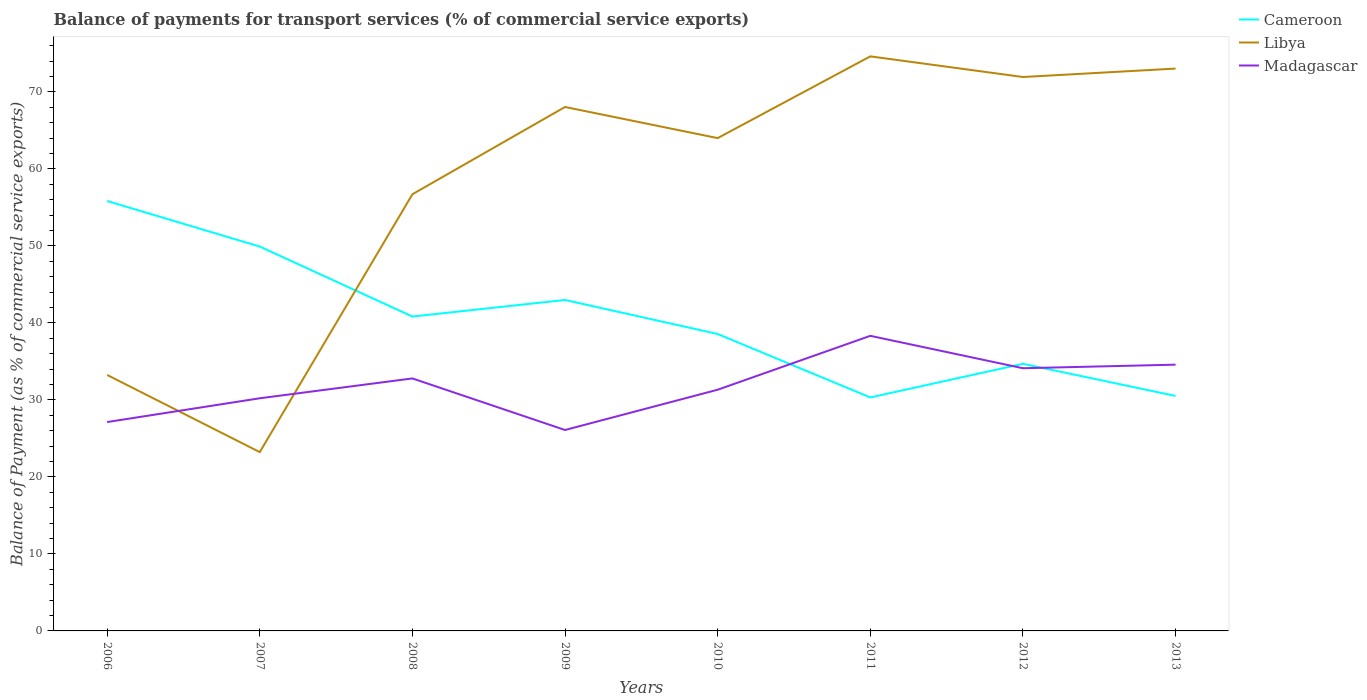Does the line corresponding to Cameroon intersect with the line corresponding to Libya?
Provide a short and direct response. Yes. Is the number of lines equal to the number of legend labels?
Your answer should be very brief. Yes. Across all years, what is the maximum balance of payments for transport services in Madagascar?
Offer a very short reply. 26.1. What is the total balance of payments for transport services in Libya in the graph?
Offer a terse response. -41.38. What is the difference between the highest and the second highest balance of payments for transport services in Libya?
Give a very brief answer. 51.4. What is the difference between the highest and the lowest balance of payments for transport services in Libya?
Ensure brevity in your answer.  5. Is the balance of payments for transport services in Cameroon strictly greater than the balance of payments for transport services in Libya over the years?
Ensure brevity in your answer.  No. How many lines are there?
Provide a short and direct response. 3. How many years are there in the graph?
Keep it short and to the point. 8. Does the graph contain any zero values?
Offer a terse response. No. How many legend labels are there?
Keep it short and to the point. 3. How are the legend labels stacked?
Keep it short and to the point. Vertical. What is the title of the graph?
Provide a succinct answer. Balance of payments for transport services (% of commercial service exports). Does "Vanuatu" appear as one of the legend labels in the graph?
Offer a very short reply. No. What is the label or title of the Y-axis?
Provide a succinct answer. Balance of Payment (as % of commercial service exports). What is the Balance of Payment (as % of commercial service exports) in Cameroon in 2006?
Your answer should be compact. 55.84. What is the Balance of Payment (as % of commercial service exports) of Libya in 2006?
Make the answer very short. 33.25. What is the Balance of Payment (as % of commercial service exports) of Madagascar in 2006?
Keep it short and to the point. 27.13. What is the Balance of Payment (as % of commercial service exports) of Cameroon in 2007?
Offer a terse response. 49.92. What is the Balance of Payment (as % of commercial service exports) of Libya in 2007?
Keep it short and to the point. 23.23. What is the Balance of Payment (as % of commercial service exports) in Madagascar in 2007?
Provide a short and direct response. 30.22. What is the Balance of Payment (as % of commercial service exports) in Cameroon in 2008?
Make the answer very short. 40.83. What is the Balance of Payment (as % of commercial service exports) in Libya in 2008?
Your answer should be very brief. 56.72. What is the Balance of Payment (as % of commercial service exports) in Madagascar in 2008?
Make the answer very short. 32.8. What is the Balance of Payment (as % of commercial service exports) of Cameroon in 2009?
Offer a very short reply. 42.99. What is the Balance of Payment (as % of commercial service exports) in Libya in 2009?
Your response must be concise. 68.05. What is the Balance of Payment (as % of commercial service exports) of Madagascar in 2009?
Ensure brevity in your answer.  26.1. What is the Balance of Payment (as % of commercial service exports) in Cameroon in 2010?
Offer a very short reply. 38.57. What is the Balance of Payment (as % of commercial service exports) in Libya in 2010?
Make the answer very short. 64.01. What is the Balance of Payment (as % of commercial service exports) of Madagascar in 2010?
Your response must be concise. 31.33. What is the Balance of Payment (as % of commercial service exports) of Cameroon in 2011?
Provide a succinct answer. 30.33. What is the Balance of Payment (as % of commercial service exports) in Libya in 2011?
Offer a terse response. 74.63. What is the Balance of Payment (as % of commercial service exports) of Madagascar in 2011?
Provide a short and direct response. 38.33. What is the Balance of Payment (as % of commercial service exports) in Cameroon in 2012?
Your answer should be compact. 34.69. What is the Balance of Payment (as % of commercial service exports) in Libya in 2012?
Give a very brief answer. 71.94. What is the Balance of Payment (as % of commercial service exports) of Madagascar in 2012?
Give a very brief answer. 34.12. What is the Balance of Payment (as % of commercial service exports) of Cameroon in 2013?
Offer a terse response. 30.52. What is the Balance of Payment (as % of commercial service exports) in Libya in 2013?
Keep it short and to the point. 73.04. What is the Balance of Payment (as % of commercial service exports) in Madagascar in 2013?
Provide a succinct answer. 34.58. Across all years, what is the maximum Balance of Payment (as % of commercial service exports) of Cameroon?
Your response must be concise. 55.84. Across all years, what is the maximum Balance of Payment (as % of commercial service exports) in Libya?
Provide a short and direct response. 74.63. Across all years, what is the maximum Balance of Payment (as % of commercial service exports) in Madagascar?
Your response must be concise. 38.33. Across all years, what is the minimum Balance of Payment (as % of commercial service exports) of Cameroon?
Offer a terse response. 30.33. Across all years, what is the minimum Balance of Payment (as % of commercial service exports) of Libya?
Offer a very short reply. 23.23. Across all years, what is the minimum Balance of Payment (as % of commercial service exports) of Madagascar?
Provide a short and direct response. 26.1. What is the total Balance of Payment (as % of commercial service exports) of Cameroon in the graph?
Your answer should be very brief. 323.69. What is the total Balance of Payment (as % of commercial service exports) of Libya in the graph?
Offer a terse response. 464.86. What is the total Balance of Payment (as % of commercial service exports) in Madagascar in the graph?
Provide a succinct answer. 254.6. What is the difference between the Balance of Payment (as % of commercial service exports) in Cameroon in 2006 and that in 2007?
Your answer should be compact. 5.92. What is the difference between the Balance of Payment (as % of commercial service exports) of Libya in 2006 and that in 2007?
Make the answer very short. 10.02. What is the difference between the Balance of Payment (as % of commercial service exports) in Madagascar in 2006 and that in 2007?
Offer a terse response. -3.09. What is the difference between the Balance of Payment (as % of commercial service exports) of Cameroon in 2006 and that in 2008?
Your answer should be compact. 15.01. What is the difference between the Balance of Payment (as % of commercial service exports) in Libya in 2006 and that in 2008?
Your answer should be very brief. -23.47. What is the difference between the Balance of Payment (as % of commercial service exports) in Madagascar in 2006 and that in 2008?
Make the answer very short. -5.67. What is the difference between the Balance of Payment (as % of commercial service exports) in Cameroon in 2006 and that in 2009?
Your answer should be very brief. 12.85. What is the difference between the Balance of Payment (as % of commercial service exports) of Libya in 2006 and that in 2009?
Your response must be concise. -34.81. What is the difference between the Balance of Payment (as % of commercial service exports) of Madagascar in 2006 and that in 2009?
Offer a very short reply. 1.03. What is the difference between the Balance of Payment (as % of commercial service exports) of Cameroon in 2006 and that in 2010?
Make the answer very short. 17.27. What is the difference between the Balance of Payment (as % of commercial service exports) of Libya in 2006 and that in 2010?
Your answer should be compact. -30.76. What is the difference between the Balance of Payment (as % of commercial service exports) of Madagascar in 2006 and that in 2010?
Your answer should be compact. -4.2. What is the difference between the Balance of Payment (as % of commercial service exports) in Cameroon in 2006 and that in 2011?
Provide a short and direct response. 25.51. What is the difference between the Balance of Payment (as % of commercial service exports) of Libya in 2006 and that in 2011?
Keep it short and to the point. -41.38. What is the difference between the Balance of Payment (as % of commercial service exports) of Madagascar in 2006 and that in 2011?
Your response must be concise. -11.2. What is the difference between the Balance of Payment (as % of commercial service exports) of Cameroon in 2006 and that in 2012?
Make the answer very short. 21.15. What is the difference between the Balance of Payment (as % of commercial service exports) of Libya in 2006 and that in 2012?
Your response must be concise. -38.7. What is the difference between the Balance of Payment (as % of commercial service exports) of Madagascar in 2006 and that in 2012?
Provide a short and direct response. -6.99. What is the difference between the Balance of Payment (as % of commercial service exports) of Cameroon in 2006 and that in 2013?
Give a very brief answer. 25.32. What is the difference between the Balance of Payment (as % of commercial service exports) of Libya in 2006 and that in 2013?
Your response must be concise. -39.79. What is the difference between the Balance of Payment (as % of commercial service exports) of Madagascar in 2006 and that in 2013?
Offer a terse response. -7.46. What is the difference between the Balance of Payment (as % of commercial service exports) in Cameroon in 2007 and that in 2008?
Provide a succinct answer. 9.09. What is the difference between the Balance of Payment (as % of commercial service exports) in Libya in 2007 and that in 2008?
Give a very brief answer. -33.49. What is the difference between the Balance of Payment (as % of commercial service exports) of Madagascar in 2007 and that in 2008?
Make the answer very short. -2.58. What is the difference between the Balance of Payment (as % of commercial service exports) in Cameroon in 2007 and that in 2009?
Provide a short and direct response. 6.94. What is the difference between the Balance of Payment (as % of commercial service exports) in Libya in 2007 and that in 2009?
Keep it short and to the point. -44.83. What is the difference between the Balance of Payment (as % of commercial service exports) of Madagascar in 2007 and that in 2009?
Provide a succinct answer. 4.12. What is the difference between the Balance of Payment (as % of commercial service exports) in Cameroon in 2007 and that in 2010?
Give a very brief answer. 11.36. What is the difference between the Balance of Payment (as % of commercial service exports) in Libya in 2007 and that in 2010?
Provide a short and direct response. -40.78. What is the difference between the Balance of Payment (as % of commercial service exports) of Madagascar in 2007 and that in 2010?
Your response must be concise. -1.11. What is the difference between the Balance of Payment (as % of commercial service exports) in Cameroon in 2007 and that in 2011?
Make the answer very short. 19.6. What is the difference between the Balance of Payment (as % of commercial service exports) in Libya in 2007 and that in 2011?
Give a very brief answer. -51.4. What is the difference between the Balance of Payment (as % of commercial service exports) in Madagascar in 2007 and that in 2011?
Offer a very short reply. -8.11. What is the difference between the Balance of Payment (as % of commercial service exports) of Cameroon in 2007 and that in 2012?
Your response must be concise. 15.23. What is the difference between the Balance of Payment (as % of commercial service exports) of Libya in 2007 and that in 2012?
Offer a terse response. -48.72. What is the difference between the Balance of Payment (as % of commercial service exports) of Madagascar in 2007 and that in 2012?
Provide a short and direct response. -3.9. What is the difference between the Balance of Payment (as % of commercial service exports) of Cameroon in 2007 and that in 2013?
Offer a terse response. 19.4. What is the difference between the Balance of Payment (as % of commercial service exports) in Libya in 2007 and that in 2013?
Your answer should be very brief. -49.81. What is the difference between the Balance of Payment (as % of commercial service exports) in Madagascar in 2007 and that in 2013?
Keep it short and to the point. -4.37. What is the difference between the Balance of Payment (as % of commercial service exports) in Cameroon in 2008 and that in 2009?
Make the answer very short. -2.15. What is the difference between the Balance of Payment (as % of commercial service exports) of Libya in 2008 and that in 2009?
Make the answer very short. -11.34. What is the difference between the Balance of Payment (as % of commercial service exports) in Madagascar in 2008 and that in 2009?
Offer a very short reply. 6.7. What is the difference between the Balance of Payment (as % of commercial service exports) in Cameroon in 2008 and that in 2010?
Your response must be concise. 2.27. What is the difference between the Balance of Payment (as % of commercial service exports) of Libya in 2008 and that in 2010?
Provide a short and direct response. -7.29. What is the difference between the Balance of Payment (as % of commercial service exports) of Madagascar in 2008 and that in 2010?
Make the answer very short. 1.47. What is the difference between the Balance of Payment (as % of commercial service exports) in Cameroon in 2008 and that in 2011?
Your response must be concise. 10.51. What is the difference between the Balance of Payment (as % of commercial service exports) of Libya in 2008 and that in 2011?
Keep it short and to the point. -17.91. What is the difference between the Balance of Payment (as % of commercial service exports) in Madagascar in 2008 and that in 2011?
Ensure brevity in your answer.  -5.53. What is the difference between the Balance of Payment (as % of commercial service exports) of Cameroon in 2008 and that in 2012?
Provide a succinct answer. 6.14. What is the difference between the Balance of Payment (as % of commercial service exports) of Libya in 2008 and that in 2012?
Make the answer very short. -15.23. What is the difference between the Balance of Payment (as % of commercial service exports) in Madagascar in 2008 and that in 2012?
Ensure brevity in your answer.  -1.32. What is the difference between the Balance of Payment (as % of commercial service exports) in Cameroon in 2008 and that in 2013?
Your response must be concise. 10.31. What is the difference between the Balance of Payment (as % of commercial service exports) of Libya in 2008 and that in 2013?
Your answer should be compact. -16.32. What is the difference between the Balance of Payment (as % of commercial service exports) in Madagascar in 2008 and that in 2013?
Provide a succinct answer. -1.79. What is the difference between the Balance of Payment (as % of commercial service exports) of Cameroon in 2009 and that in 2010?
Offer a very short reply. 4.42. What is the difference between the Balance of Payment (as % of commercial service exports) of Libya in 2009 and that in 2010?
Make the answer very short. 4.04. What is the difference between the Balance of Payment (as % of commercial service exports) in Madagascar in 2009 and that in 2010?
Provide a succinct answer. -5.23. What is the difference between the Balance of Payment (as % of commercial service exports) of Cameroon in 2009 and that in 2011?
Keep it short and to the point. 12.66. What is the difference between the Balance of Payment (as % of commercial service exports) of Libya in 2009 and that in 2011?
Provide a short and direct response. -6.57. What is the difference between the Balance of Payment (as % of commercial service exports) of Madagascar in 2009 and that in 2011?
Give a very brief answer. -12.23. What is the difference between the Balance of Payment (as % of commercial service exports) in Cameroon in 2009 and that in 2012?
Your response must be concise. 8.29. What is the difference between the Balance of Payment (as % of commercial service exports) of Libya in 2009 and that in 2012?
Your answer should be compact. -3.89. What is the difference between the Balance of Payment (as % of commercial service exports) of Madagascar in 2009 and that in 2012?
Make the answer very short. -8.02. What is the difference between the Balance of Payment (as % of commercial service exports) of Cameroon in 2009 and that in 2013?
Your response must be concise. 12.46. What is the difference between the Balance of Payment (as % of commercial service exports) of Libya in 2009 and that in 2013?
Offer a very short reply. -4.99. What is the difference between the Balance of Payment (as % of commercial service exports) of Madagascar in 2009 and that in 2013?
Ensure brevity in your answer.  -8.49. What is the difference between the Balance of Payment (as % of commercial service exports) in Cameroon in 2010 and that in 2011?
Give a very brief answer. 8.24. What is the difference between the Balance of Payment (as % of commercial service exports) of Libya in 2010 and that in 2011?
Your response must be concise. -10.62. What is the difference between the Balance of Payment (as % of commercial service exports) in Madagascar in 2010 and that in 2011?
Ensure brevity in your answer.  -7. What is the difference between the Balance of Payment (as % of commercial service exports) of Cameroon in 2010 and that in 2012?
Provide a short and direct response. 3.87. What is the difference between the Balance of Payment (as % of commercial service exports) of Libya in 2010 and that in 2012?
Offer a terse response. -7.94. What is the difference between the Balance of Payment (as % of commercial service exports) of Madagascar in 2010 and that in 2012?
Make the answer very short. -2.79. What is the difference between the Balance of Payment (as % of commercial service exports) of Cameroon in 2010 and that in 2013?
Offer a terse response. 8.05. What is the difference between the Balance of Payment (as % of commercial service exports) in Libya in 2010 and that in 2013?
Offer a terse response. -9.03. What is the difference between the Balance of Payment (as % of commercial service exports) of Madagascar in 2010 and that in 2013?
Your response must be concise. -3.26. What is the difference between the Balance of Payment (as % of commercial service exports) in Cameroon in 2011 and that in 2012?
Keep it short and to the point. -4.37. What is the difference between the Balance of Payment (as % of commercial service exports) of Libya in 2011 and that in 2012?
Make the answer very short. 2.68. What is the difference between the Balance of Payment (as % of commercial service exports) of Madagascar in 2011 and that in 2012?
Give a very brief answer. 4.21. What is the difference between the Balance of Payment (as % of commercial service exports) in Cameroon in 2011 and that in 2013?
Keep it short and to the point. -0.2. What is the difference between the Balance of Payment (as % of commercial service exports) of Libya in 2011 and that in 2013?
Give a very brief answer. 1.59. What is the difference between the Balance of Payment (as % of commercial service exports) in Madagascar in 2011 and that in 2013?
Your answer should be compact. 3.74. What is the difference between the Balance of Payment (as % of commercial service exports) in Cameroon in 2012 and that in 2013?
Your response must be concise. 4.17. What is the difference between the Balance of Payment (as % of commercial service exports) of Libya in 2012 and that in 2013?
Give a very brief answer. -1.1. What is the difference between the Balance of Payment (as % of commercial service exports) in Madagascar in 2012 and that in 2013?
Give a very brief answer. -0.46. What is the difference between the Balance of Payment (as % of commercial service exports) in Cameroon in 2006 and the Balance of Payment (as % of commercial service exports) in Libya in 2007?
Give a very brief answer. 32.61. What is the difference between the Balance of Payment (as % of commercial service exports) in Cameroon in 2006 and the Balance of Payment (as % of commercial service exports) in Madagascar in 2007?
Provide a succinct answer. 25.62. What is the difference between the Balance of Payment (as % of commercial service exports) of Libya in 2006 and the Balance of Payment (as % of commercial service exports) of Madagascar in 2007?
Offer a terse response. 3.03. What is the difference between the Balance of Payment (as % of commercial service exports) of Cameroon in 2006 and the Balance of Payment (as % of commercial service exports) of Libya in 2008?
Your response must be concise. -0.88. What is the difference between the Balance of Payment (as % of commercial service exports) of Cameroon in 2006 and the Balance of Payment (as % of commercial service exports) of Madagascar in 2008?
Offer a terse response. 23.04. What is the difference between the Balance of Payment (as % of commercial service exports) of Libya in 2006 and the Balance of Payment (as % of commercial service exports) of Madagascar in 2008?
Provide a short and direct response. 0.45. What is the difference between the Balance of Payment (as % of commercial service exports) of Cameroon in 2006 and the Balance of Payment (as % of commercial service exports) of Libya in 2009?
Provide a short and direct response. -12.21. What is the difference between the Balance of Payment (as % of commercial service exports) of Cameroon in 2006 and the Balance of Payment (as % of commercial service exports) of Madagascar in 2009?
Provide a short and direct response. 29.74. What is the difference between the Balance of Payment (as % of commercial service exports) of Libya in 2006 and the Balance of Payment (as % of commercial service exports) of Madagascar in 2009?
Keep it short and to the point. 7.15. What is the difference between the Balance of Payment (as % of commercial service exports) of Cameroon in 2006 and the Balance of Payment (as % of commercial service exports) of Libya in 2010?
Provide a succinct answer. -8.17. What is the difference between the Balance of Payment (as % of commercial service exports) of Cameroon in 2006 and the Balance of Payment (as % of commercial service exports) of Madagascar in 2010?
Provide a succinct answer. 24.51. What is the difference between the Balance of Payment (as % of commercial service exports) in Libya in 2006 and the Balance of Payment (as % of commercial service exports) in Madagascar in 2010?
Give a very brief answer. 1.92. What is the difference between the Balance of Payment (as % of commercial service exports) of Cameroon in 2006 and the Balance of Payment (as % of commercial service exports) of Libya in 2011?
Offer a terse response. -18.79. What is the difference between the Balance of Payment (as % of commercial service exports) of Cameroon in 2006 and the Balance of Payment (as % of commercial service exports) of Madagascar in 2011?
Provide a short and direct response. 17.51. What is the difference between the Balance of Payment (as % of commercial service exports) in Libya in 2006 and the Balance of Payment (as % of commercial service exports) in Madagascar in 2011?
Your response must be concise. -5.08. What is the difference between the Balance of Payment (as % of commercial service exports) of Cameroon in 2006 and the Balance of Payment (as % of commercial service exports) of Libya in 2012?
Keep it short and to the point. -16.11. What is the difference between the Balance of Payment (as % of commercial service exports) of Cameroon in 2006 and the Balance of Payment (as % of commercial service exports) of Madagascar in 2012?
Your response must be concise. 21.72. What is the difference between the Balance of Payment (as % of commercial service exports) of Libya in 2006 and the Balance of Payment (as % of commercial service exports) of Madagascar in 2012?
Your response must be concise. -0.87. What is the difference between the Balance of Payment (as % of commercial service exports) in Cameroon in 2006 and the Balance of Payment (as % of commercial service exports) in Libya in 2013?
Provide a succinct answer. -17.2. What is the difference between the Balance of Payment (as % of commercial service exports) in Cameroon in 2006 and the Balance of Payment (as % of commercial service exports) in Madagascar in 2013?
Your answer should be compact. 21.26. What is the difference between the Balance of Payment (as % of commercial service exports) in Libya in 2006 and the Balance of Payment (as % of commercial service exports) in Madagascar in 2013?
Provide a short and direct response. -1.34. What is the difference between the Balance of Payment (as % of commercial service exports) of Cameroon in 2007 and the Balance of Payment (as % of commercial service exports) of Libya in 2008?
Your answer should be very brief. -6.79. What is the difference between the Balance of Payment (as % of commercial service exports) in Cameroon in 2007 and the Balance of Payment (as % of commercial service exports) in Madagascar in 2008?
Make the answer very short. 17.13. What is the difference between the Balance of Payment (as % of commercial service exports) of Libya in 2007 and the Balance of Payment (as % of commercial service exports) of Madagascar in 2008?
Offer a very short reply. -9.57. What is the difference between the Balance of Payment (as % of commercial service exports) of Cameroon in 2007 and the Balance of Payment (as % of commercial service exports) of Libya in 2009?
Offer a terse response. -18.13. What is the difference between the Balance of Payment (as % of commercial service exports) of Cameroon in 2007 and the Balance of Payment (as % of commercial service exports) of Madagascar in 2009?
Offer a very short reply. 23.83. What is the difference between the Balance of Payment (as % of commercial service exports) in Libya in 2007 and the Balance of Payment (as % of commercial service exports) in Madagascar in 2009?
Provide a succinct answer. -2.87. What is the difference between the Balance of Payment (as % of commercial service exports) in Cameroon in 2007 and the Balance of Payment (as % of commercial service exports) in Libya in 2010?
Provide a succinct answer. -14.09. What is the difference between the Balance of Payment (as % of commercial service exports) in Cameroon in 2007 and the Balance of Payment (as % of commercial service exports) in Madagascar in 2010?
Offer a very short reply. 18.59. What is the difference between the Balance of Payment (as % of commercial service exports) of Libya in 2007 and the Balance of Payment (as % of commercial service exports) of Madagascar in 2010?
Provide a succinct answer. -8.1. What is the difference between the Balance of Payment (as % of commercial service exports) of Cameroon in 2007 and the Balance of Payment (as % of commercial service exports) of Libya in 2011?
Make the answer very short. -24.7. What is the difference between the Balance of Payment (as % of commercial service exports) in Cameroon in 2007 and the Balance of Payment (as % of commercial service exports) in Madagascar in 2011?
Ensure brevity in your answer.  11.59. What is the difference between the Balance of Payment (as % of commercial service exports) of Libya in 2007 and the Balance of Payment (as % of commercial service exports) of Madagascar in 2011?
Offer a terse response. -15.1. What is the difference between the Balance of Payment (as % of commercial service exports) in Cameroon in 2007 and the Balance of Payment (as % of commercial service exports) in Libya in 2012?
Offer a terse response. -22.02. What is the difference between the Balance of Payment (as % of commercial service exports) of Cameroon in 2007 and the Balance of Payment (as % of commercial service exports) of Madagascar in 2012?
Give a very brief answer. 15.8. What is the difference between the Balance of Payment (as % of commercial service exports) of Libya in 2007 and the Balance of Payment (as % of commercial service exports) of Madagascar in 2012?
Your answer should be very brief. -10.89. What is the difference between the Balance of Payment (as % of commercial service exports) of Cameroon in 2007 and the Balance of Payment (as % of commercial service exports) of Libya in 2013?
Ensure brevity in your answer.  -23.12. What is the difference between the Balance of Payment (as % of commercial service exports) of Cameroon in 2007 and the Balance of Payment (as % of commercial service exports) of Madagascar in 2013?
Your answer should be very brief. 15.34. What is the difference between the Balance of Payment (as % of commercial service exports) in Libya in 2007 and the Balance of Payment (as % of commercial service exports) in Madagascar in 2013?
Offer a terse response. -11.36. What is the difference between the Balance of Payment (as % of commercial service exports) in Cameroon in 2008 and the Balance of Payment (as % of commercial service exports) in Libya in 2009?
Offer a very short reply. -27.22. What is the difference between the Balance of Payment (as % of commercial service exports) in Cameroon in 2008 and the Balance of Payment (as % of commercial service exports) in Madagascar in 2009?
Keep it short and to the point. 14.74. What is the difference between the Balance of Payment (as % of commercial service exports) of Libya in 2008 and the Balance of Payment (as % of commercial service exports) of Madagascar in 2009?
Make the answer very short. 30.62. What is the difference between the Balance of Payment (as % of commercial service exports) in Cameroon in 2008 and the Balance of Payment (as % of commercial service exports) in Libya in 2010?
Your answer should be compact. -23.18. What is the difference between the Balance of Payment (as % of commercial service exports) in Cameroon in 2008 and the Balance of Payment (as % of commercial service exports) in Madagascar in 2010?
Your answer should be very brief. 9.51. What is the difference between the Balance of Payment (as % of commercial service exports) of Libya in 2008 and the Balance of Payment (as % of commercial service exports) of Madagascar in 2010?
Give a very brief answer. 25.39. What is the difference between the Balance of Payment (as % of commercial service exports) of Cameroon in 2008 and the Balance of Payment (as % of commercial service exports) of Libya in 2011?
Your answer should be very brief. -33.79. What is the difference between the Balance of Payment (as % of commercial service exports) in Cameroon in 2008 and the Balance of Payment (as % of commercial service exports) in Madagascar in 2011?
Provide a short and direct response. 2.51. What is the difference between the Balance of Payment (as % of commercial service exports) in Libya in 2008 and the Balance of Payment (as % of commercial service exports) in Madagascar in 2011?
Ensure brevity in your answer.  18.39. What is the difference between the Balance of Payment (as % of commercial service exports) of Cameroon in 2008 and the Balance of Payment (as % of commercial service exports) of Libya in 2012?
Your answer should be compact. -31.11. What is the difference between the Balance of Payment (as % of commercial service exports) of Cameroon in 2008 and the Balance of Payment (as % of commercial service exports) of Madagascar in 2012?
Your response must be concise. 6.71. What is the difference between the Balance of Payment (as % of commercial service exports) of Libya in 2008 and the Balance of Payment (as % of commercial service exports) of Madagascar in 2012?
Your response must be concise. 22.6. What is the difference between the Balance of Payment (as % of commercial service exports) in Cameroon in 2008 and the Balance of Payment (as % of commercial service exports) in Libya in 2013?
Offer a very short reply. -32.21. What is the difference between the Balance of Payment (as % of commercial service exports) in Cameroon in 2008 and the Balance of Payment (as % of commercial service exports) in Madagascar in 2013?
Your answer should be very brief. 6.25. What is the difference between the Balance of Payment (as % of commercial service exports) of Libya in 2008 and the Balance of Payment (as % of commercial service exports) of Madagascar in 2013?
Your answer should be compact. 22.13. What is the difference between the Balance of Payment (as % of commercial service exports) in Cameroon in 2009 and the Balance of Payment (as % of commercial service exports) in Libya in 2010?
Your answer should be very brief. -21.02. What is the difference between the Balance of Payment (as % of commercial service exports) in Cameroon in 2009 and the Balance of Payment (as % of commercial service exports) in Madagascar in 2010?
Your answer should be very brief. 11.66. What is the difference between the Balance of Payment (as % of commercial service exports) in Libya in 2009 and the Balance of Payment (as % of commercial service exports) in Madagascar in 2010?
Keep it short and to the point. 36.72. What is the difference between the Balance of Payment (as % of commercial service exports) of Cameroon in 2009 and the Balance of Payment (as % of commercial service exports) of Libya in 2011?
Your answer should be compact. -31.64. What is the difference between the Balance of Payment (as % of commercial service exports) of Cameroon in 2009 and the Balance of Payment (as % of commercial service exports) of Madagascar in 2011?
Your answer should be compact. 4.66. What is the difference between the Balance of Payment (as % of commercial service exports) in Libya in 2009 and the Balance of Payment (as % of commercial service exports) in Madagascar in 2011?
Your answer should be very brief. 29.72. What is the difference between the Balance of Payment (as % of commercial service exports) of Cameroon in 2009 and the Balance of Payment (as % of commercial service exports) of Libya in 2012?
Ensure brevity in your answer.  -28.96. What is the difference between the Balance of Payment (as % of commercial service exports) in Cameroon in 2009 and the Balance of Payment (as % of commercial service exports) in Madagascar in 2012?
Ensure brevity in your answer.  8.87. What is the difference between the Balance of Payment (as % of commercial service exports) of Libya in 2009 and the Balance of Payment (as % of commercial service exports) of Madagascar in 2012?
Keep it short and to the point. 33.93. What is the difference between the Balance of Payment (as % of commercial service exports) in Cameroon in 2009 and the Balance of Payment (as % of commercial service exports) in Libya in 2013?
Provide a succinct answer. -30.05. What is the difference between the Balance of Payment (as % of commercial service exports) of Cameroon in 2009 and the Balance of Payment (as % of commercial service exports) of Madagascar in 2013?
Provide a short and direct response. 8.4. What is the difference between the Balance of Payment (as % of commercial service exports) of Libya in 2009 and the Balance of Payment (as % of commercial service exports) of Madagascar in 2013?
Your answer should be compact. 33.47. What is the difference between the Balance of Payment (as % of commercial service exports) of Cameroon in 2010 and the Balance of Payment (as % of commercial service exports) of Libya in 2011?
Offer a very short reply. -36.06. What is the difference between the Balance of Payment (as % of commercial service exports) of Cameroon in 2010 and the Balance of Payment (as % of commercial service exports) of Madagascar in 2011?
Give a very brief answer. 0.24. What is the difference between the Balance of Payment (as % of commercial service exports) of Libya in 2010 and the Balance of Payment (as % of commercial service exports) of Madagascar in 2011?
Ensure brevity in your answer.  25.68. What is the difference between the Balance of Payment (as % of commercial service exports) of Cameroon in 2010 and the Balance of Payment (as % of commercial service exports) of Libya in 2012?
Ensure brevity in your answer.  -33.38. What is the difference between the Balance of Payment (as % of commercial service exports) of Cameroon in 2010 and the Balance of Payment (as % of commercial service exports) of Madagascar in 2012?
Provide a succinct answer. 4.45. What is the difference between the Balance of Payment (as % of commercial service exports) in Libya in 2010 and the Balance of Payment (as % of commercial service exports) in Madagascar in 2012?
Your answer should be compact. 29.89. What is the difference between the Balance of Payment (as % of commercial service exports) of Cameroon in 2010 and the Balance of Payment (as % of commercial service exports) of Libya in 2013?
Keep it short and to the point. -34.47. What is the difference between the Balance of Payment (as % of commercial service exports) of Cameroon in 2010 and the Balance of Payment (as % of commercial service exports) of Madagascar in 2013?
Provide a short and direct response. 3.98. What is the difference between the Balance of Payment (as % of commercial service exports) of Libya in 2010 and the Balance of Payment (as % of commercial service exports) of Madagascar in 2013?
Provide a short and direct response. 29.43. What is the difference between the Balance of Payment (as % of commercial service exports) in Cameroon in 2011 and the Balance of Payment (as % of commercial service exports) in Libya in 2012?
Make the answer very short. -41.62. What is the difference between the Balance of Payment (as % of commercial service exports) of Cameroon in 2011 and the Balance of Payment (as % of commercial service exports) of Madagascar in 2012?
Your answer should be compact. -3.79. What is the difference between the Balance of Payment (as % of commercial service exports) in Libya in 2011 and the Balance of Payment (as % of commercial service exports) in Madagascar in 2012?
Your answer should be very brief. 40.51. What is the difference between the Balance of Payment (as % of commercial service exports) in Cameroon in 2011 and the Balance of Payment (as % of commercial service exports) in Libya in 2013?
Keep it short and to the point. -42.72. What is the difference between the Balance of Payment (as % of commercial service exports) in Cameroon in 2011 and the Balance of Payment (as % of commercial service exports) in Madagascar in 2013?
Provide a short and direct response. -4.26. What is the difference between the Balance of Payment (as % of commercial service exports) of Libya in 2011 and the Balance of Payment (as % of commercial service exports) of Madagascar in 2013?
Provide a short and direct response. 40.04. What is the difference between the Balance of Payment (as % of commercial service exports) in Cameroon in 2012 and the Balance of Payment (as % of commercial service exports) in Libya in 2013?
Your answer should be compact. -38.35. What is the difference between the Balance of Payment (as % of commercial service exports) in Cameroon in 2012 and the Balance of Payment (as % of commercial service exports) in Madagascar in 2013?
Offer a very short reply. 0.11. What is the difference between the Balance of Payment (as % of commercial service exports) in Libya in 2012 and the Balance of Payment (as % of commercial service exports) in Madagascar in 2013?
Give a very brief answer. 37.36. What is the average Balance of Payment (as % of commercial service exports) of Cameroon per year?
Your answer should be compact. 40.46. What is the average Balance of Payment (as % of commercial service exports) in Libya per year?
Your answer should be compact. 58.11. What is the average Balance of Payment (as % of commercial service exports) in Madagascar per year?
Provide a succinct answer. 31.82. In the year 2006, what is the difference between the Balance of Payment (as % of commercial service exports) of Cameroon and Balance of Payment (as % of commercial service exports) of Libya?
Provide a succinct answer. 22.59. In the year 2006, what is the difference between the Balance of Payment (as % of commercial service exports) of Cameroon and Balance of Payment (as % of commercial service exports) of Madagascar?
Provide a succinct answer. 28.71. In the year 2006, what is the difference between the Balance of Payment (as % of commercial service exports) of Libya and Balance of Payment (as % of commercial service exports) of Madagascar?
Your answer should be compact. 6.12. In the year 2007, what is the difference between the Balance of Payment (as % of commercial service exports) of Cameroon and Balance of Payment (as % of commercial service exports) of Libya?
Offer a terse response. 26.7. In the year 2007, what is the difference between the Balance of Payment (as % of commercial service exports) in Cameroon and Balance of Payment (as % of commercial service exports) in Madagascar?
Provide a succinct answer. 19.7. In the year 2007, what is the difference between the Balance of Payment (as % of commercial service exports) of Libya and Balance of Payment (as % of commercial service exports) of Madagascar?
Your answer should be very brief. -6.99. In the year 2008, what is the difference between the Balance of Payment (as % of commercial service exports) in Cameroon and Balance of Payment (as % of commercial service exports) in Libya?
Offer a terse response. -15.88. In the year 2008, what is the difference between the Balance of Payment (as % of commercial service exports) of Cameroon and Balance of Payment (as % of commercial service exports) of Madagascar?
Your answer should be compact. 8.04. In the year 2008, what is the difference between the Balance of Payment (as % of commercial service exports) of Libya and Balance of Payment (as % of commercial service exports) of Madagascar?
Provide a short and direct response. 23.92. In the year 2009, what is the difference between the Balance of Payment (as % of commercial service exports) in Cameroon and Balance of Payment (as % of commercial service exports) in Libya?
Provide a short and direct response. -25.07. In the year 2009, what is the difference between the Balance of Payment (as % of commercial service exports) of Cameroon and Balance of Payment (as % of commercial service exports) of Madagascar?
Your answer should be very brief. 16.89. In the year 2009, what is the difference between the Balance of Payment (as % of commercial service exports) in Libya and Balance of Payment (as % of commercial service exports) in Madagascar?
Provide a short and direct response. 41.96. In the year 2010, what is the difference between the Balance of Payment (as % of commercial service exports) in Cameroon and Balance of Payment (as % of commercial service exports) in Libya?
Keep it short and to the point. -25.44. In the year 2010, what is the difference between the Balance of Payment (as % of commercial service exports) in Cameroon and Balance of Payment (as % of commercial service exports) in Madagascar?
Provide a succinct answer. 7.24. In the year 2010, what is the difference between the Balance of Payment (as % of commercial service exports) of Libya and Balance of Payment (as % of commercial service exports) of Madagascar?
Your answer should be very brief. 32.68. In the year 2011, what is the difference between the Balance of Payment (as % of commercial service exports) in Cameroon and Balance of Payment (as % of commercial service exports) in Libya?
Your answer should be very brief. -44.3. In the year 2011, what is the difference between the Balance of Payment (as % of commercial service exports) of Cameroon and Balance of Payment (as % of commercial service exports) of Madagascar?
Offer a very short reply. -8. In the year 2011, what is the difference between the Balance of Payment (as % of commercial service exports) of Libya and Balance of Payment (as % of commercial service exports) of Madagascar?
Your response must be concise. 36.3. In the year 2012, what is the difference between the Balance of Payment (as % of commercial service exports) of Cameroon and Balance of Payment (as % of commercial service exports) of Libya?
Keep it short and to the point. -37.25. In the year 2012, what is the difference between the Balance of Payment (as % of commercial service exports) of Cameroon and Balance of Payment (as % of commercial service exports) of Madagascar?
Give a very brief answer. 0.57. In the year 2012, what is the difference between the Balance of Payment (as % of commercial service exports) in Libya and Balance of Payment (as % of commercial service exports) in Madagascar?
Offer a very short reply. 37.83. In the year 2013, what is the difference between the Balance of Payment (as % of commercial service exports) of Cameroon and Balance of Payment (as % of commercial service exports) of Libya?
Give a very brief answer. -42.52. In the year 2013, what is the difference between the Balance of Payment (as % of commercial service exports) of Cameroon and Balance of Payment (as % of commercial service exports) of Madagascar?
Provide a succinct answer. -4.06. In the year 2013, what is the difference between the Balance of Payment (as % of commercial service exports) in Libya and Balance of Payment (as % of commercial service exports) in Madagascar?
Give a very brief answer. 38.46. What is the ratio of the Balance of Payment (as % of commercial service exports) of Cameroon in 2006 to that in 2007?
Provide a succinct answer. 1.12. What is the ratio of the Balance of Payment (as % of commercial service exports) of Libya in 2006 to that in 2007?
Provide a short and direct response. 1.43. What is the ratio of the Balance of Payment (as % of commercial service exports) of Madagascar in 2006 to that in 2007?
Provide a succinct answer. 0.9. What is the ratio of the Balance of Payment (as % of commercial service exports) of Cameroon in 2006 to that in 2008?
Keep it short and to the point. 1.37. What is the ratio of the Balance of Payment (as % of commercial service exports) of Libya in 2006 to that in 2008?
Keep it short and to the point. 0.59. What is the ratio of the Balance of Payment (as % of commercial service exports) in Madagascar in 2006 to that in 2008?
Offer a very short reply. 0.83. What is the ratio of the Balance of Payment (as % of commercial service exports) in Cameroon in 2006 to that in 2009?
Provide a succinct answer. 1.3. What is the ratio of the Balance of Payment (as % of commercial service exports) in Libya in 2006 to that in 2009?
Give a very brief answer. 0.49. What is the ratio of the Balance of Payment (as % of commercial service exports) in Madagascar in 2006 to that in 2009?
Offer a very short reply. 1.04. What is the ratio of the Balance of Payment (as % of commercial service exports) of Cameroon in 2006 to that in 2010?
Your answer should be very brief. 1.45. What is the ratio of the Balance of Payment (as % of commercial service exports) in Libya in 2006 to that in 2010?
Provide a succinct answer. 0.52. What is the ratio of the Balance of Payment (as % of commercial service exports) of Madagascar in 2006 to that in 2010?
Give a very brief answer. 0.87. What is the ratio of the Balance of Payment (as % of commercial service exports) of Cameroon in 2006 to that in 2011?
Give a very brief answer. 1.84. What is the ratio of the Balance of Payment (as % of commercial service exports) of Libya in 2006 to that in 2011?
Give a very brief answer. 0.45. What is the ratio of the Balance of Payment (as % of commercial service exports) of Madagascar in 2006 to that in 2011?
Your answer should be very brief. 0.71. What is the ratio of the Balance of Payment (as % of commercial service exports) in Cameroon in 2006 to that in 2012?
Provide a short and direct response. 1.61. What is the ratio of the Balance of Payment (as % of commercial service exports) of Libya in 2006 to that in 2012?
Offer a terse response. 0.46. What is the ratio of the Balance of Payment (as % of commercial service exports) in Madagascar in 2006 to that in 2012?
Your answer should be compact. 0.8. What is the ratio of the Balance of Payment (as % of commercial service exports) in Cameroon in 2006 to that in 2013?
Your answer should be very brief. 1.83. What is the ratio of the Balance of Payment (as % of commercial service exports) in Libya in 2006 to that in 2013?
Ensure brevity in your answer.  0.46. What is the ratio of the Balance of Payment (as % of commercial service exports) of Madagascar in 2006 to that in 2013?
Give a very brief answer. 0.78. What is the ratio of the Balance of Payment (as % of commercial service exports) in Cameroon in 2007 to that in 2008?
Provide a succinct answer. 1.22. What is the ratio of the Balance of Payment (as % of commercial service exports) of Libya in 2007 to that in 2008?
Make the answer very short. 0.41. What is the ratio of the Balance of Payment (as % of commercial service exports) of Madagascar in 2007 to that in 2008?
Provide a short and direct response. 0.92. What is the ratio of the Balance of Payment (as % of commercial service exports) in Cameroon in 2007 to that in 2009?
Give a very brief answer. 1.16. What is the ratio of the Balance of Payment (as % of commercial service exports) in Libya in 2007 to that in 2009?
Keep it short and to the point. 0.34. What is the ratio of the Balance of Payment (as % of commercial service exports) of Madagascar in 2007 to that in 2009?
Provide a succinct answer. 1.16. What is the ratio of the Balance of Payment (as % of commercial service exports) in Cameroon in 2007 to that in 2010?
Give a very brief answer. 1.29. What is the ratio of the Balance of Payment (as % of commercial service exports) of Libya in 2007 to that in 2010?
Your answer should be compact. 0.36. What is the ratio of the Balance of Payment (as % of commercial service exports) in Madagascar in 2007 to that in 2010?
Your answer should be very brief. 0.96. What is the ratio of the Balance of Payment (as % of commercial service exports) of Cameroon in 2007 to that in 2011?
Keep it short and to the point. 1.65. What is the ratio of the Balance of Payment (as % of commercial service exports) of Libya in 2007 to that in 2011?
Make the answer very short. 0.31. What is the ratio of the Balance of Payment (as % of commercial service exports) in Madagascar in 2007 to that in 2011?
Keep it short and to the point. 0.79. What is the ratio of the Balance of Payment (as % of commercial service exports) of Cameroon in 2007 to that in 2012?
Provide a short and direct response. 1.44. What is the ratio of the Balance of Payment (as % of commercial service exports) in Libya in 2007 to that in 2012?
Your answer should be very brief. 0.32. What is the ratio of the Balance of Payment (as % of commercial service exports) of Madagascar in 2007 to that in 2012?
Offer a very short reply. 0.89. What is the ratio of the Balance of Payment (as % of commercial service exports) in Cameroon in 2007 to that in 2013?
Offer a very short reply. 1.64. What is the ratio of the Balance of Payment (as % of commercial service exports) in Libya in 2007 to that in 2013?
Offer a very short reply. 0.32. What is the ratio of the Balance of Payment (as % of commercial service exports) of Madagascar in 2007 to that in 2013?
Offer a terse response. 0.87. What is the ratio of the Balance of Payment (as % of commercial service exports) in Cameroon in 2008 to that in 2009?
Your response must be concise. 0.95. What is the ratio of the Balance of Payment (as % of commercial service exports) of Libya in 2008 to that in 2009?
Offer a terse response. 0.83. What is the ratio of the Balance of Payment (as % of commercial service exports) in Madagascar in 2008 to that in 2009?
Make the answer very short. 1.26. What is the ratio of the Balance of Payment (as % of commercial service exports) in Cameroon in 2008 to that in 2010?
Give a very brief answer. 1.06. What is the ratio of the Balance of Payment (as % of commercial service exports) of Libya in 2008 to that in 2010?
Make the answer very short. 0.89. What is the ratio of the Balance of Payment (as % of commercial service exports) of Madagascar in 2008 to that in 2010?
Provide a short and direct response. 1.05. What is the ratio of the Balance of Payment (as % of commercial service exports) in Cameroon in 2008 to that in 2011?
Provide a succinct answer. 1.35. What is the ratio of the Balance of Payment (as % of commercial service exports) in Libya in 2008 to that in 2011?
Offer a very short reply. 0.76. What is the ratio of the Balance of Payment (as % of commercial service exports) of Madagascar in 2008 to that in 2011?
Your response must be concise. 0.86. What is the ratio of the Balance of Payment (as % of commercial service exports) of Cameroon in 2008 to that in 2012?
Your answer should be compact. 1.18. What is the ratio of the Balance of Payment (as % of commercial service exports) of Libya in 2008 to that in 2012?
Your response must be concise. 0.79. What is the ratio of the Balance of Payment (as % of commercial service exports) in Madagascar in 2008 to that in 2012?
Your answer should be very brief. 0.96. What is the ratio of the Balance of Payment (as % of commercial service exports) of Cameroon in 2008 to that in 2013?
Give a very brief answer. 1.34. What is the ratio of the Balance of Payment (as % of commercial service exports) in Libya in 2008 to that in 2013?
Your answer should be compact. 0.78. What is the ratio of the Balance of Payment (as % of commercial service exports) of Madagascar in 2008 to that in 2013?
Give a very brief answer. 0.95. What is the ratio of the Balance of Payment (as % of commercial service exports) of Cameroon in 2009 to that in 2010?
Keep it short and to the point. 1.11. What is the ratio of the Balance of Payment (as % of commercial service exports) in Libya in 2009 to that in 2010?
Offer a terse response. 1.06. What is the ratio of the Balance of Payment (as % of commercial service exports) in Madagascar in 2009 to that in 2010?
Offer a terse response. 0.83. What is the ratio of the Balance of Payment (as % of commercial service exports) of Cameroon in 2009 to that in 2011?
Your answer should be very brief. 1.42. What is the ratio of the Balance of Payment (as % of commercial service exports) of Libya in 2009 to that in 2011?
Make the answer very short. 0.91. What is the ratio of the Balance of Payment (as % of commercial service exports) in Madagascar in 2009 to that in 2011?
Offer a terse response. 0.68. What is the ratio of the Balance of Payment (as % of commercial service exports) of Cameroon in 2009 to that in 2012?
Make the answer very short. 1.24. What is the ratio of the Balance of Payment (as % of commercial service exports) in Libya in 2009 to that in 2012?
Your answer should be compact. 0.95. What is the ratio of the Balance of Payment (as % of commercial service exports) in Madagascar in 2009 to that in 2012?
Offer a very short reply. 0.76. What is the ratio of the Balance of Payment (as % of commercial service exports) of Cameroon in 2009 to that in 2013?
Provide a short and direct response. 1.41. What is the ratio of the Balance of Payment (as % of commercial service exports) of Libya in 2009 to that in 2013?
Provide a succinct answer. 0.93. What is the ratio of the Balance of Payment (as % of commercial service exports) in Madagascar in 2009 to that in 2013?
Your answer should be compact. 0.75. What is the ratio of the Balance of Payment (as % of commercial service exports) in Cameroon in 2010 to that in 2011?
Your answer should be very brief. 1.27. What is the ratio of the Balance of Payment (as % of commercial service exports) of Libya in 2010 to that in 2011?
Offer a terse response. 0.86. What is the ratio of the Balance of Payment (as % of commercial service exports) of Madagascar in 2010 to that in 2011?
Keep it short and to the point. 0.82. What is the ratio of the Balance of Payment (as % of commercial service exports) in Cameroon in 2010 to that in 2012?
Offer a very short reply. 1.11. What is the ratio of the Balance of Payment (as % of commercial service exports) in Libya in 2010 to that in 2012?
Offer a terse response. 0.89. What is the ratio of the Balance of Payment (as % of commercial service exports) in Madagascar in 2010 to that in 2012?
Offer a very short reply. 0.92. What is the ratio of the Balance of Payment (as % of commercial service exports) in Cameroon in 2010 to that in 2013?
Provide a short and direct response. 1.26. What is the ratio of the Balance of Payment (as % of commercial service exports) in Libya in 2010 to that in 2013?
Provide a short and direct response. 0.88. What is the ratio of the Balance of Payment (as % of commercial service exports) in Madagascar in 2010 to that in 2013?
Your answer should be compact. 0.91. What is the ratio of the Balance of Payment (as % of commercial service exports) of Cameroon in 2011 to that in 2012?
Your response must be concise. 0.87. What is the ratio of the Balance of Payment (as % of commercial service exports) of Libya in 2011 to that in 2012?
Provide a succinct answer. 1.04. What is the ratio of the Balance of Payment (as % of commercial service exports) of Madagascar in 2011 to that in 2012?
Your response must be concise. 1.12. What is the ratio of the Balance of Payment (as % of commercial service exports) in Cameroon in 2011 to that in 2013?
Ensure brevity in your answer.  0.99. What is the ratio of the Balance of Payment (as % of commercial service exports) in Libya in 2011 to that in 2013?
Provide a short and direct response. 1.02. What is the ratio of the Balance of Payment (as % of commercial service exports) in Madagascar in 2011 to that in 2013?
Your answer should be very brief. 1.11. What is the ratio of the Balance of Payment (as % of commercial service exports) in Cameroon in 2012 to that in 2013?
Your answer should be very brief. 1.14. What is the ratio of the Balance of Payment (as % of commercial service exports) of Libya in 2012 to that in 2013?
Offer a very short reply. 0.98. What is the ratio of the Balance of Payment (as % of commercial service exports) of Madagascar in 2012 to that in 2013?
Keep it short and to the point. 0.99. What is the difference between the highest and the second highest Balance of Payment (as % of commercial service exports) of Cameroon?
Ensure brevity in your answer.  5.92. What is the difference between the highest and the second highest Balance of Payment (as % of commercial service exports) in Libya?
Your answer should be very brief. 1.59. What is the difference between the highest and the second highest Balance of Payment (as % of commercial service exports) of Madagascar?
Provide a short and direct response. 3.74. What is the difference between the highest and the lowest Balance of Payment (as % of commercial service exports) of Cameroon?
Your answer should be compact. 25.51. What is the difference between the highest and the lowest Balance of Payment (as % of commercial service exports) of Libya?
Make the answer very short. 51.4. What is the difference between the highest and the lowest Balance of Payment (as % of commercial service exports) of Madagascar?
Your answer should be very brief. 12.23. 